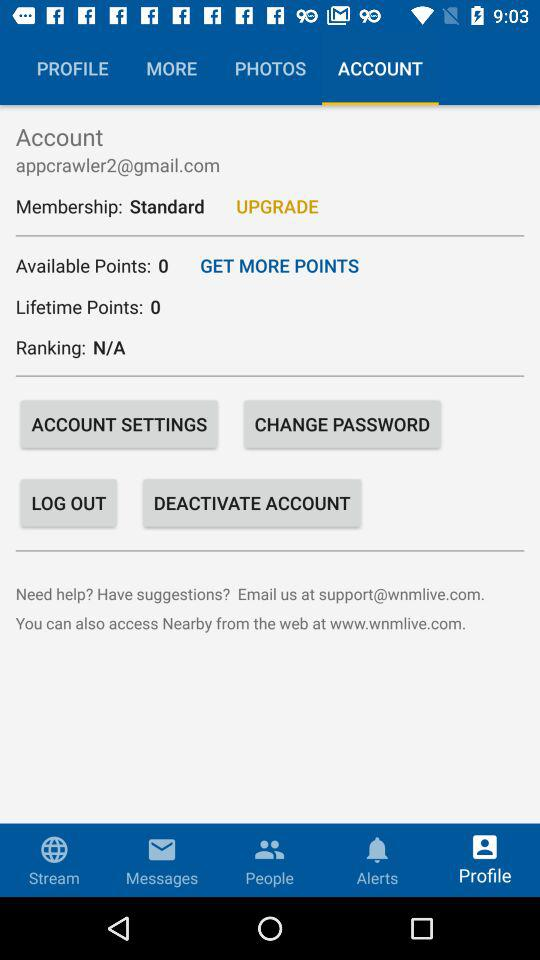How many "Available Points" are there? The "Available Points" are 0. 